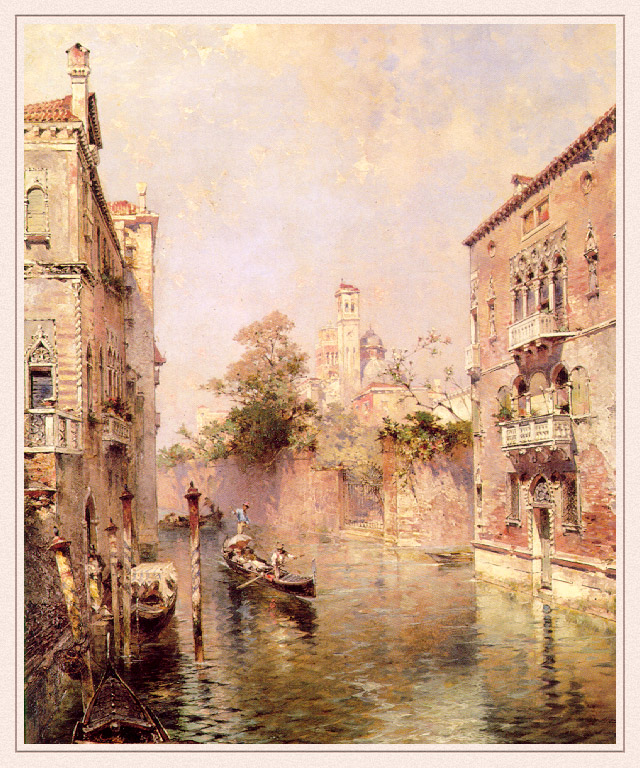Can you describe the main features of this image for me? The image captures a serene and picturesque scene from Venice, famed for its intricate canal system. This artwork, executed in an impressionist style, masterfully portrays the transient effects of light and color, which are hallmarks of this artistic approach. Central to the composition is a gentle canal with a gondola gliding smoothly across its calm waters. Flanking the canal are intricately detailed buildings, featuring elegant balconies, arches, and a blend of architectural designs that enhance the charm of the scenery. The color palette is dominated by soothing shades of pink, blue, and green, which instill a dreamlike ambiance to the scene. This image evokes a sense of tranquility and timeless beauty, perfectly encapsulating Venice's allure. It represents a moment frozen in time, beautifully illustrating the harmonious blend of natural and man-made beauty characteristic of landscape art. 